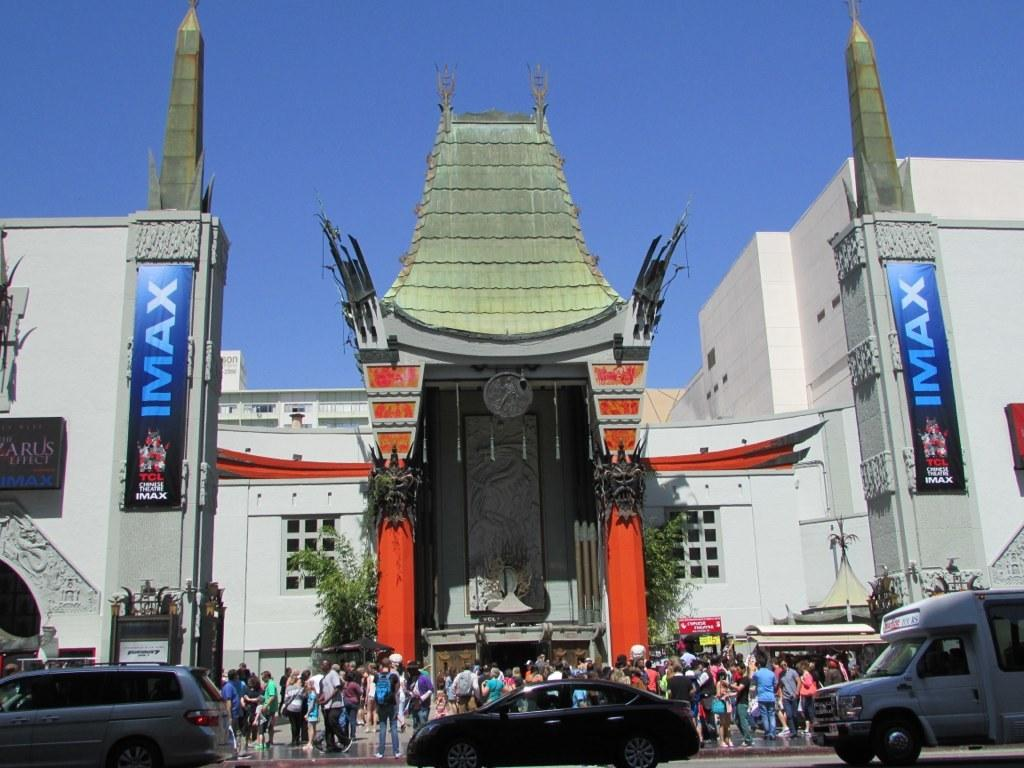What can be seen on the road in the image? There are vehicles and people on the road in the image. What is visible in the background of the image? There is a building, trees, boards, and the sky visible in the background of the image. Can you describe any objects in the background of the image? There are some objects in the background of the image. What type of lettuce is being used as a trampoline in the image? There is no lettuce or trampoline present in the image. 